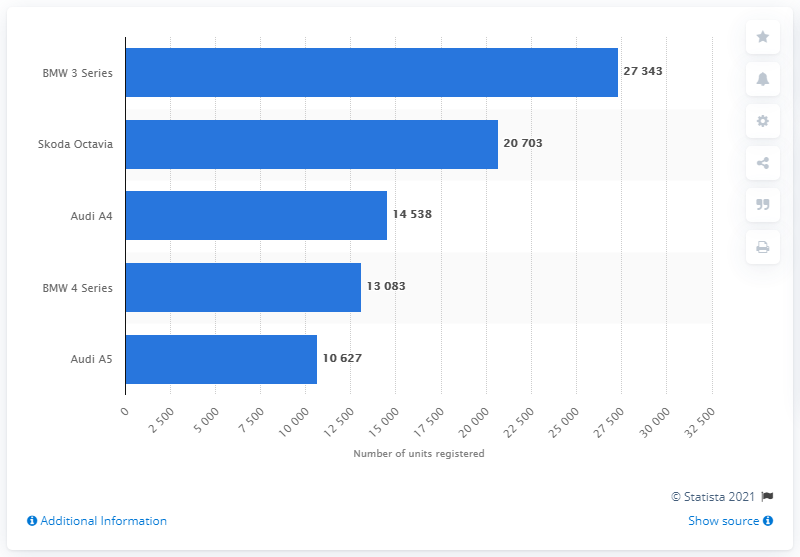Highlight a few significant elements in this photo. The Skoda Octavia is the only upper medium car that is produced by German automakers BMW and Audi. 